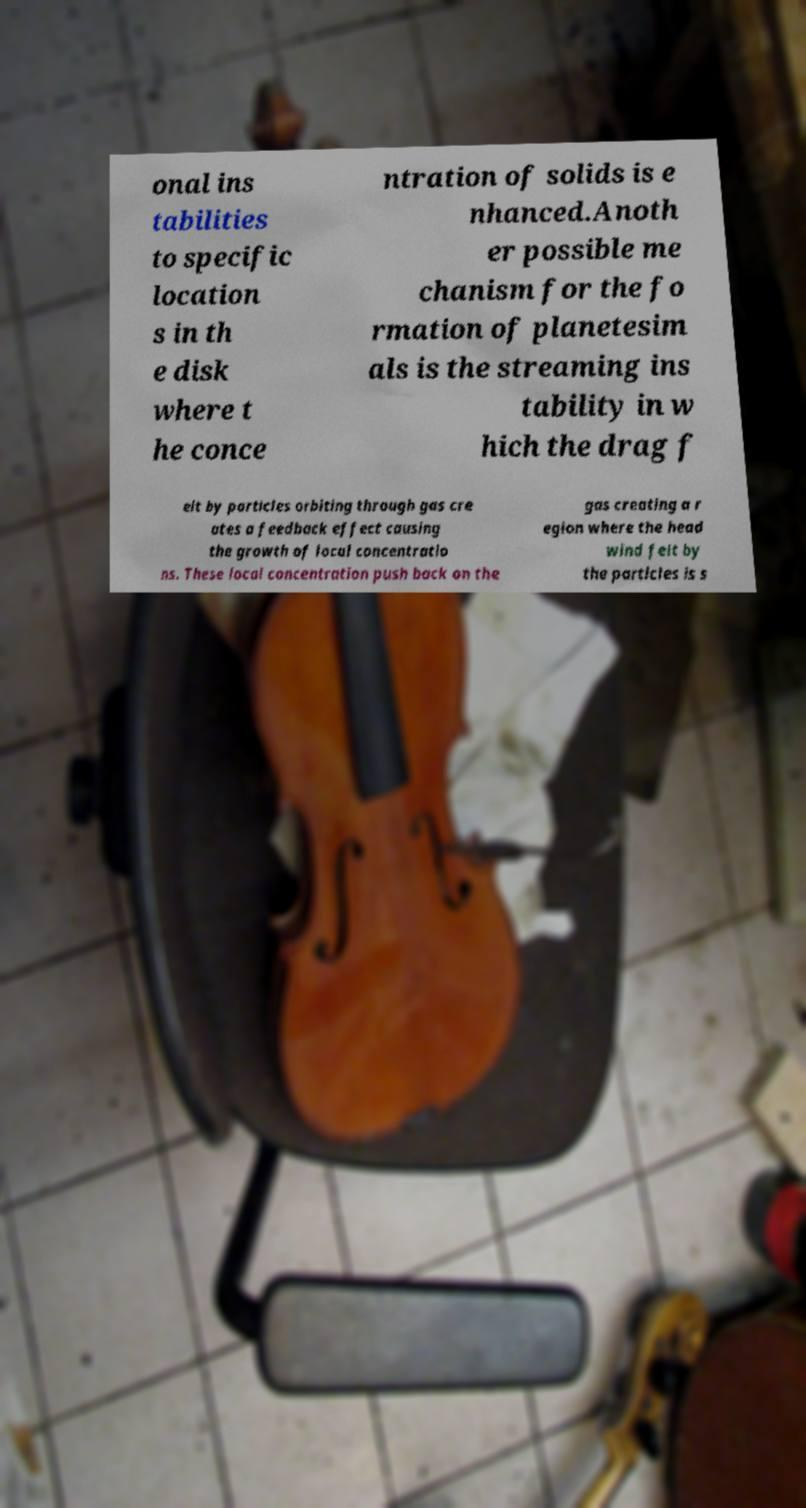For documentation purposes, I need the text within this image transcribed. Could you provide that? onal ins tabilities to specific location s in th e disk where t he conce ntration of solids is e nhanced.Anoth er possible me chanism for the fo rmation of planetesim als is the streaming ins tability in w hich the drag f elt by particles orbiting through gas cre ates a feedback effect causing the growth of local concentratio ns. These local concentration push back on the gas creating a r egion where the head wind felt by the particles is s 